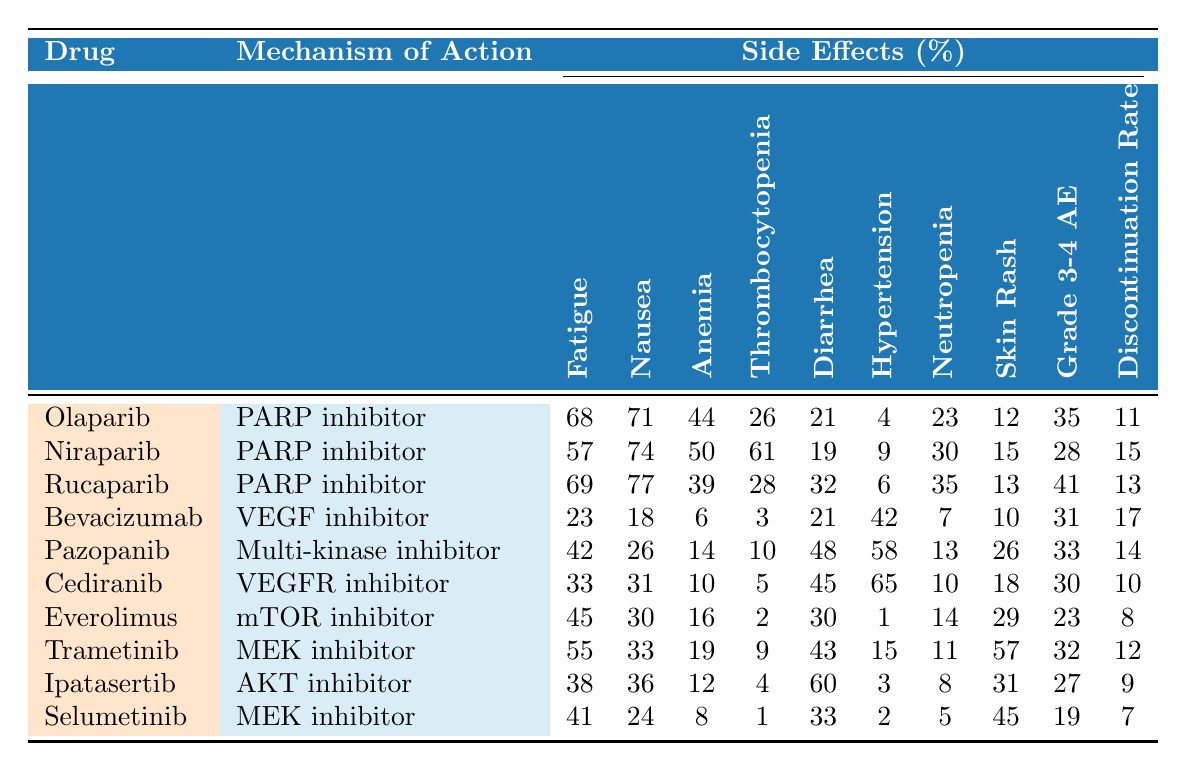What is the percentage of patients experiencing fatigue while taking Olaparib? According to the table, Olaparib has a fatigue percentage of 68%.
Answer: 68% Which drug has the highest percentage of nausea as a side effect? Rucaparib has the highest nausea percentage at 77%.
Answer: Rucaparib What is the rate of thrombocytopenia for Bevacizumab? The table shows that Bevacizumab has a thrombocytopenia percentage of 3%.
Answer: 3% Calculate the average percentage of anemia side effects for all listed drugs. The anemia percentages for all drugs are added: (44 + 50 + 39 + 6 + 14 + 10 + 16 + 19 + 12 + 8) = 218; since there are 10 drugs, the average is 218/10 = 21.8%.
Answer: 21.8% Is the discontinuation rate for Cediranib lower than 10%? The table indicates the discontinuation rate for Cediranib is 10%, which is not lower than 10%.
Answer: No Which medication shows the lowest proportion of patients experiencing hypertension? Selumetinib has the lowest hypertension percentage at 2%.
Answer: Selumetinib What is the overall percentage of Grade 3-4 adverse events among all drugs? The percentages of Grade 3-4 adverse events are: (35 + 28 + 41 + 31 + 33 + 30 + 23 + 32 + 27 + 19) =  328; the average is 328 / 10 = 32.8%.
Answer: 32.8% Identify the drug with the highest discontinuation rate. The drug with the highest discontinuation rate is Bevacizumab at 17%.
Answer: Bevacizumab Is the percentage of patients with diarrhea higher for Rucaparib compared to Niraparib? Rucaparib has a diarrhea percentage of 32%, while Niraparib has 19%, so Rucaparib's percentage is higher.
Answer: Yes What is the difference in fatigue percentage between Olaparib and Rucaparib? Olaparib's fatigue percentage is 68%, and Rucaparib's is 69%; the difference is 69 - 68 = 1%.
Answer: 1% 